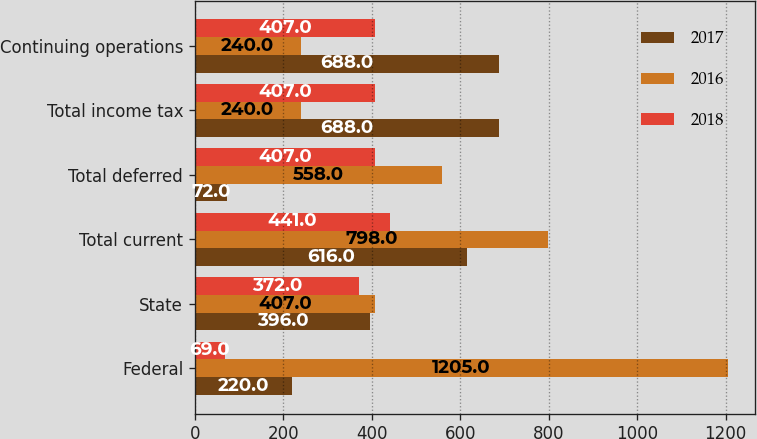Convert chart. <chart><loc_0><loc_0><loc_500><loc_500><stacked_bar_chart><ecel><fcel>Federal<fcel>State<fcel>Total current<fcel>Total deferred<fcel>Total income tax<fcel>Continuing operations<nl><fcel>2017<fcel>220<fcel>396<fcel>616<fcel>72<fcel>688<fcel>688<nl><fcel>2016<fcel>1205<fcel>407<fcel>798<fcel>558<fcel>240<fcel>240<nl><fcel>2018<fcel>69<fcel>372<fcel>441<fcel>407<fcel>407<fcel>407<nl></chart> 